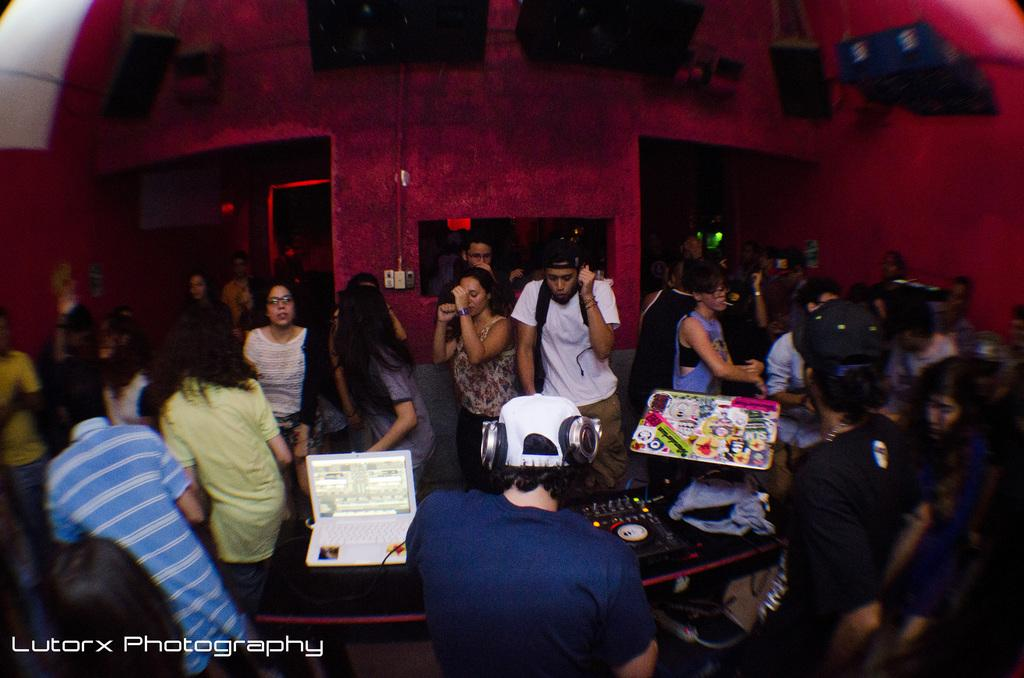How many people are in the image? There are persons in the image, but the exact number cannot be determined from the provided facts. What electronic device is visible in the image? There is a laptop in the image, which is an electronic device. What is the bag used for in the image? The bag's purpose cannot be determined from the provided facts, but it is present in the image. What objects are on the table in the image? There are objects on a table in the image, but the specific objects cannot be determined from the provided facts. What can be seen in the background of the image? There are objects and walls in the background of the image, but the specific objects and the appearance of the walls cannot be determined from the provided facts. What type of swing can be seen in the image? There is no swing present in the image. What kind of pipe is visible in the background of the image? There is no pipe visible in the image. 